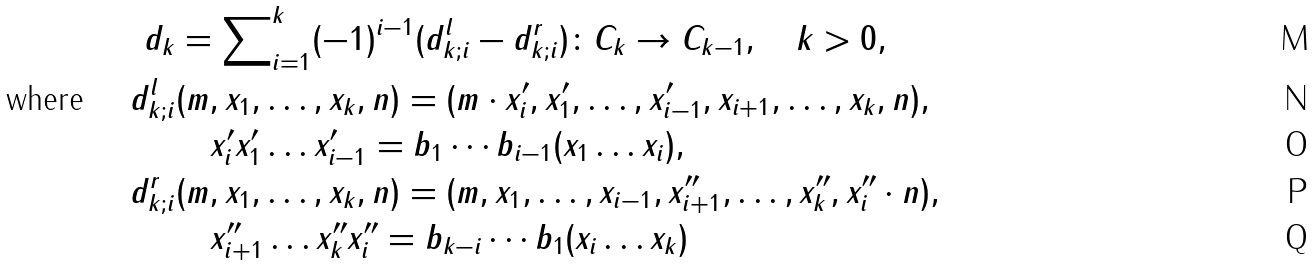<formula> <loc_0><loc_0><loc_500><loc_500>d _ { k } & = \sum \nolimits _ { i = 1 } ^ { k } ( - 1 ) ^ { i - 1 } ( d _ { k ; i } ^ { l } - d _ { k ; i } ^ { r } ) \colon C _ { k } \to C _ { k - 1 } , \quad k > 0 , \\ \text {where } \quad d _ { k ; i } ^ { l } & ( m , x _ { 1 } , \dots , x _ { k } , n ) = ( m \cdot x ^ { \prime } _ { i } , x ^ { \prime } _ { 1 } , \dots , x ^ { \prime } _ { i - 1 } , x _ { i + 1 } , \dots , x _ { k } , n ) , \\ & \quad x ^ { \prime } _ { i } x ^ { \prime } _ { 1 } \dots x ^ { \prime } _ { i - 1 } = b _ { 1 } \cdots b _ { i - 1 } ( x _ { 1 } \dots x _ { i } ) , \\ d _ { k ; i } ^ { r } & ( m , x _ { 1 } , \dots , x _ { k } , n ) = ( m , x _ { 1 } , \dots , x _ { i - 1 } , x ^ { \prime \prime } _ { i + 1 } , \dots , x ^ { \prime \prime } _ { k } , x ^ { \prime \prime } _ { i } \cdot n ) , \\ & \quad x ^ { \prime \prime } _ { i + 1 } \dots x ^ { \prime \prime } _ { k } x ^ { \prime \prime } _ { i } = b _ { k - i } \cdots b _ { 1 } ( x _ { i } \dots x _ { k } )</formula> 